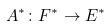Convert formula to latex. <formula><loc_0><loc_0><loc_500><loc_500>A ^ { * } \colon F ^ { * } \to E ^ { * }</formula> 